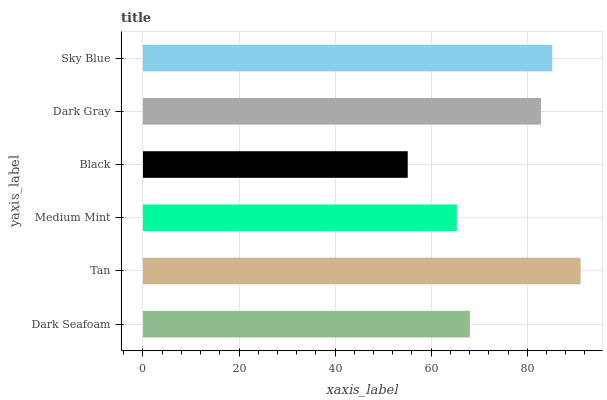Is Black the minimum?
Answer yes or no. Yes. Is Tan the maximum?
Answer yes or no. Yes. Is Medium Mint the minimum?
Answer yes or no. No. Is Medium Mint the maximum?
Answer yes or no. No. Is Tan greater than Medium Mint?
Answer yes or no. Yes. Is Medium Mint less than Tan?
Answer yes or no. Yes. Is Medium Mint greater than Tan?
Answer yes or no. No. Is Tan less than Medium Mint?
Answer yes or no. No. Is Dark Gray the high median?
Answer yes or no. Yes. Is Dark Seafoam the low median?
Answer yes or no. Yes. Is Black the high median?
Answer yes or no. No. Is Dark Gray the low median?
Answer yes or no. No. 